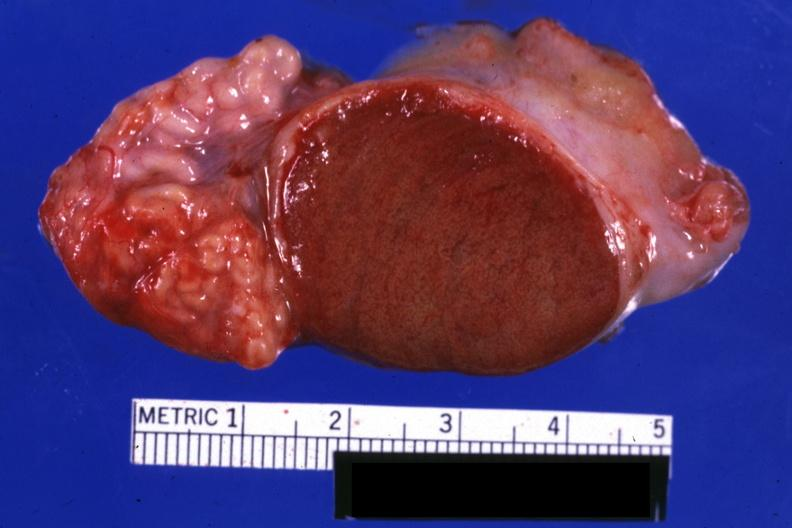what does this image show?
Answer the question using a single word or phrase. Excellent close-up view sliced open testicle with intact epididymis 